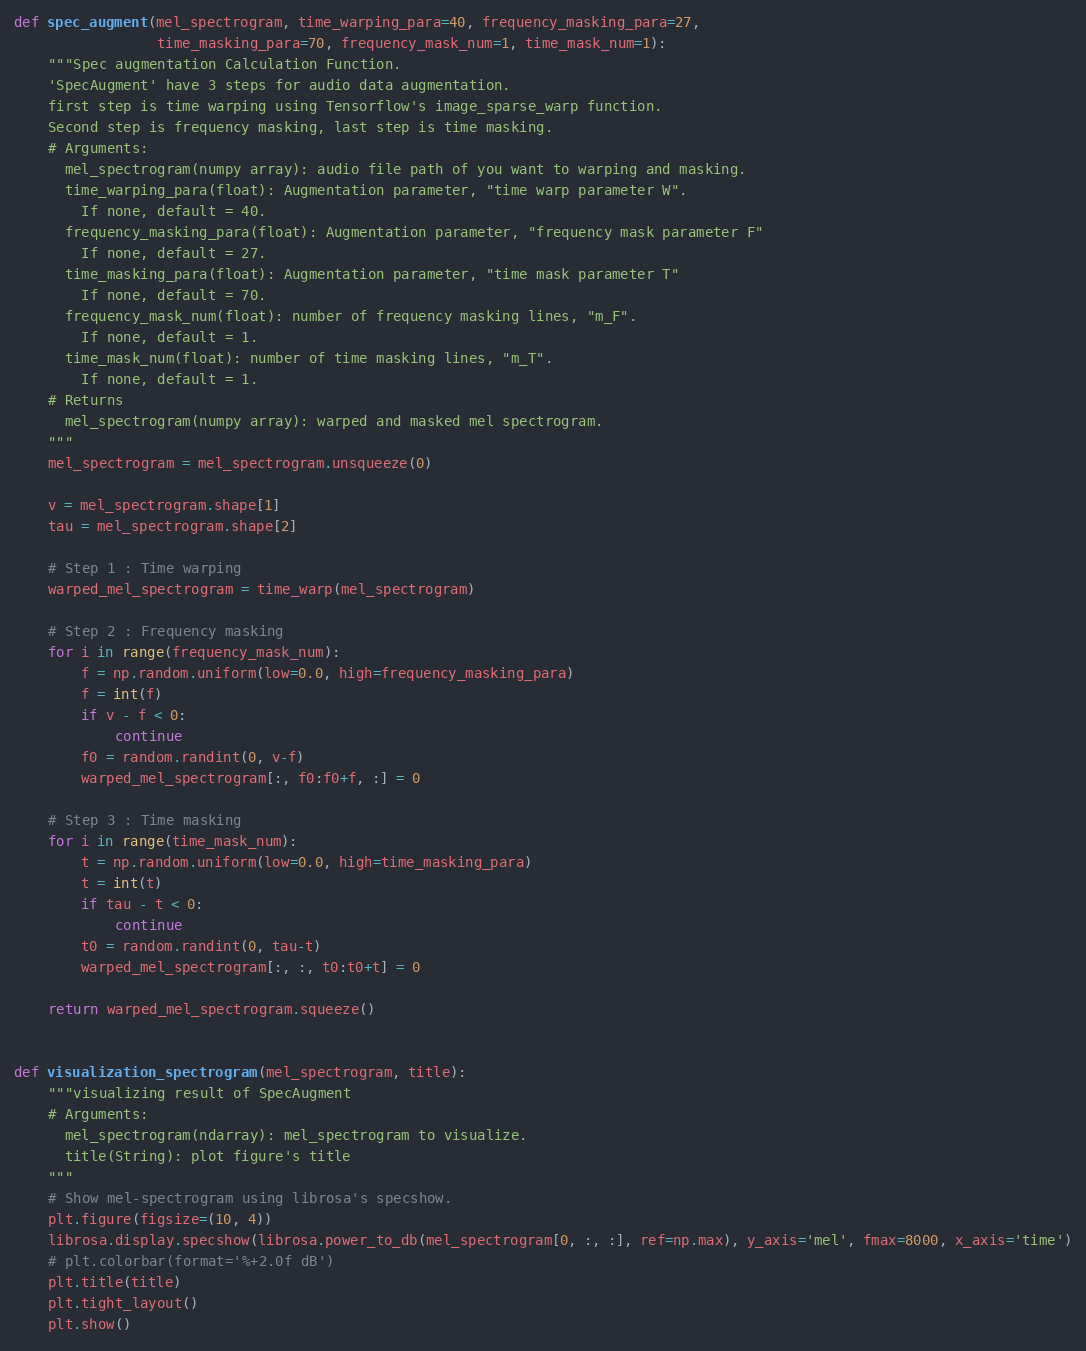Convert code to text. <code><loc_0><loc_0><loc_500><loc_500><_Python_>def spec_augment(mel_spectrogram, time_warping_para=40, frequency_masking_para=27,
                 time_masking_para=70, frequency_mask_num=1, time_mask_num=1):
    """Spec augmentation Calculation Function.
    'SpecAugment' have 3 steps for audio data augmentation.
    first step is time warping using Tensorflow's image_sparse_warp function.
    Second step is frequency masking, last step is time masking.
    # Arguments:
      mel_spectrogram(numpy array): audio file path of you want to warping and masking.
      time_warping_para(float): Augmentation parameter, "time warp parameter W".
        If none, default = 40.
      frequency_masking_para(float): Augmentation parameter, "frequency mask parameter F"
        If none, default = 27.
      time_masking_para(float): Augmentation parameter, "time mask parameter T"
        If none, default = 70.
      frequency_mask_num(float): number of frequency masking lines, "m_F".
        If none, default = 1.
      time_mask_num(float): number of time masking lines, "m_T".
        If none, default = 1.
    # Returns
      mel_spectrogram(numpy array): warped and masked mel spectrogram.
    """
    mel_spectrogram = mel_spectrogram.unsqueeze(0)

    v = mel_spectrogram.shape[1]
    tau = mel_spectrogram.shape[2]

    # Step 1 : Time warping
    warped_mel_spectrogram = time_warp(mel_spectrogram)

    # Step 2 : Frequency masking
    for i in range(frequency_mask_num):
        f = np.random.uniform(low=0.0, high=frequency_masking_para)
        f = int(f)
        if v - f < 0:
            continue
        f0 = random.randint(0, v-f)
        warped_mel_spectrogram[:, f0:f0+f, :] = 0

    # Step 3 : Time masking
    for i in range(time_mask_num):
        t = np.random.uniform(low=0.0, high=time_masking_para)
        t = int(t)
        if tau - t < 0:
            continue
        t0 = random.randint(0, tau-t)
        warped_mel_spectrogram[:, :, t0:t0+t] = 0

    return warped_mel_spectrogram.squeeze()


def visualization_spectrogram(mel_spectrogram, title):
    """visualizing result of SpecAugment
    # Arguments:
      mel_spectrogram(ndarray): mel_spectrogram to visualize.
      title(String): plot figure's title
    """
    # Show mel-spectrogram using librosa's specshow.
    plt.figure(figsize=(10, 4))
    librosa.display.specshow(librosa.power_to_db(mel_spectrogram[0, :, :], ref=np.max), y_axis='mel', fmax=8000, x_axis='time')
    # plt.colorbar(format='%+2.0f dB')
    plt.title(title)
    plt.tight_layout()
    plt.show()</code> 